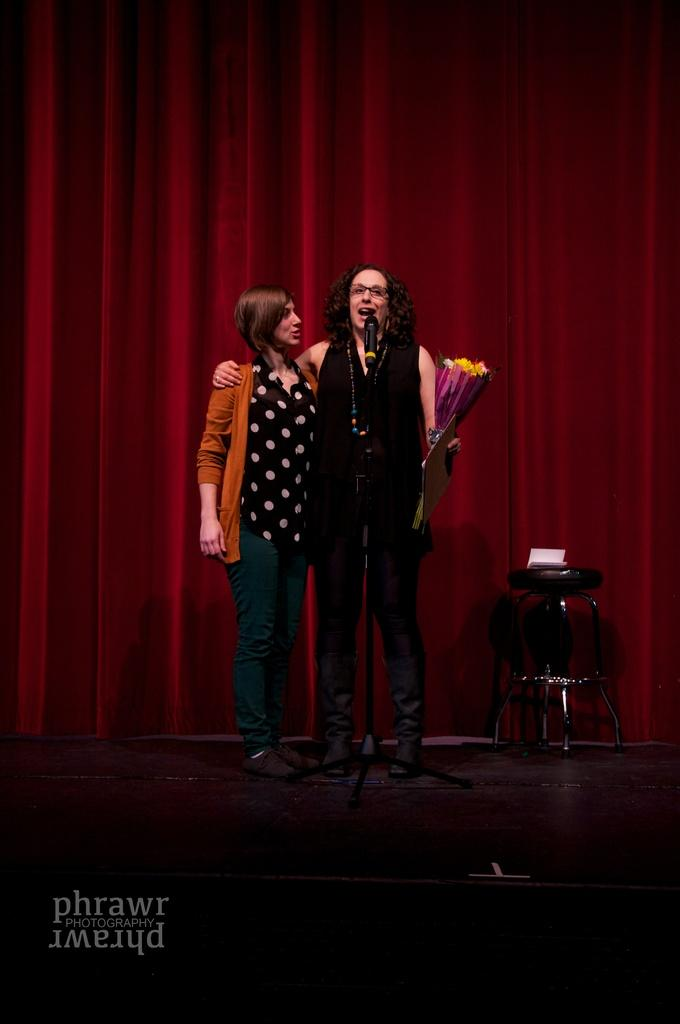How many women are present in the image? There are two women in the image. Where are the women located in the image? The women are standing on a stage. What are the women doing in the image? The women are in front of a mic. What color is the curtain in the background of the image? There is a maroon color curtain in the background of the image. How many ducks are visible in the image? There are no ducks present in the image. What type of snake can be seen slithering on the stage in the image? There is no snake present in the image; the women are the main subjects on the stage. 